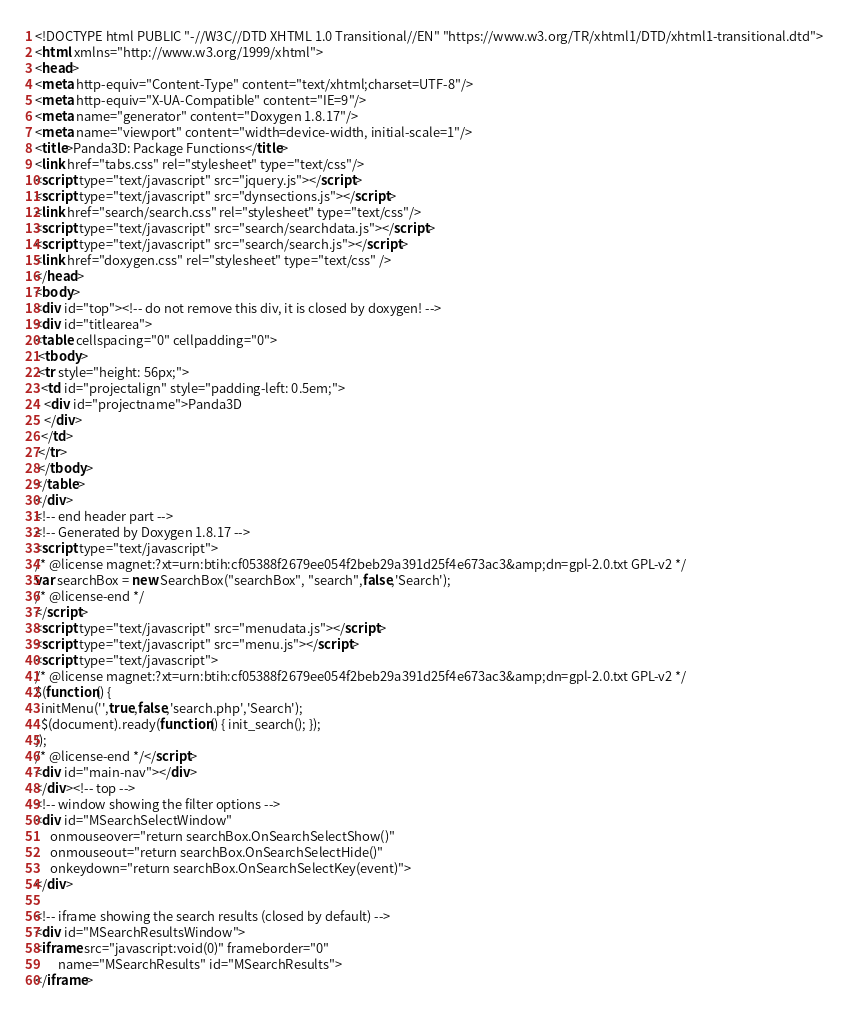Convert code to text. <code><loc_0><loc_0><loc_500><loc_500><_HTML_><!DOCTYPE html PUBLIC "-//W3C//DTD XHTML 1.0 Transitional//EN" "https://www.w3.org/TR/xhtml1/DTD/xhtml1-transitional.dtd">
<html xmlns="http://www.w3.org/1999/xhtml">
<head>
<meta http-equiv="Content-Type" content="text/xhtml;charset=UTF-8"/>
<meta http-equiv="X-UA-Compatible" content="IE=9"/>
<meta name="generator" content="Doxygen 1.8.17"/>
<meta name="viewport" content="width=device-width, initial-scale=1"/>
<title>Panda3D: Package Functions</title>
<link href="tabs.css" rel="stylesheet" type="text/css"/>
<script type="text/javascript" src="jquery.js"></script>
<script type="text/javascript" src="dynsections.js"></script>
<link href="search/search.css" rel="stylesheet" type="text/css"/>
<script type="text/javascript" src="search/searchdata.js"></script>
<script type="text/javascript" src="search/search.js"></script>
<link href="doxygen.css" rel="stylesheet" type="text/css" />
</head>
<body>
<div id="top"><!-- do not remove this div, it is closed by doxygen! -->
<div id="titlearea">
<table cellspacing="0" cellpadding="0">
 <tbody>
 <tr style="height: 56px;">
  <td id="projectalign" style="padding-left: 0.5em;">
   <div id="projectname">Panda3D
   </div>
  </td>
 </tr>
 </tbody>
</table>
</div>
<!-- end header part -->
<!-- Generated by Doxygen 1.8.17 -->
<script type="text/javascript">
/* @license magnet:?xt=urn:btih:cf05388f2679ee054f2beb29a391d25f4e673ac3&amp;dn=gpl-2.0.txt GPL-v2 */
var searchBox = new SearchBox("searchBox", "search",false,'Search');
/* @license-end */
</script>
<script type="text/javascript" src="menudata.js"></script>
<script type="text/javascript" src="menu.js"></script>
<script type="text/javascript">
/* @license magnet:?xt=urn:btih:cf05388f2679ee054f2beb29a391d25f4e673ac3&amp;dn=gpl-2.0.txt GPL-v2 */
$(function() {
  initMenu('',true,false,'search.php','Search');
  $(document).ready(function() { init_search(); });
});
/* @license-end */</script>
<div id="main-nav"></div>
</div><!-- top -->
<!-- window showing the filter options -->
<div id="MSearchSelectWindow"
     onmouseover="return searchBox.OnSearchSelectShow()"
     onmouseout="return searchBox.OnSearchSelectHide()"
     onkeydown="return searchBox.OnSearchSelectKey(event)">
</div>

<!-- iframe showing the search results (closed by default) -->
<div id="MSearchResultsWindow">
<iframe src="javascript:void(0)" frameborder="0" 
        name="MSearchResults" id="MSearchResults">
</iframe></code> 